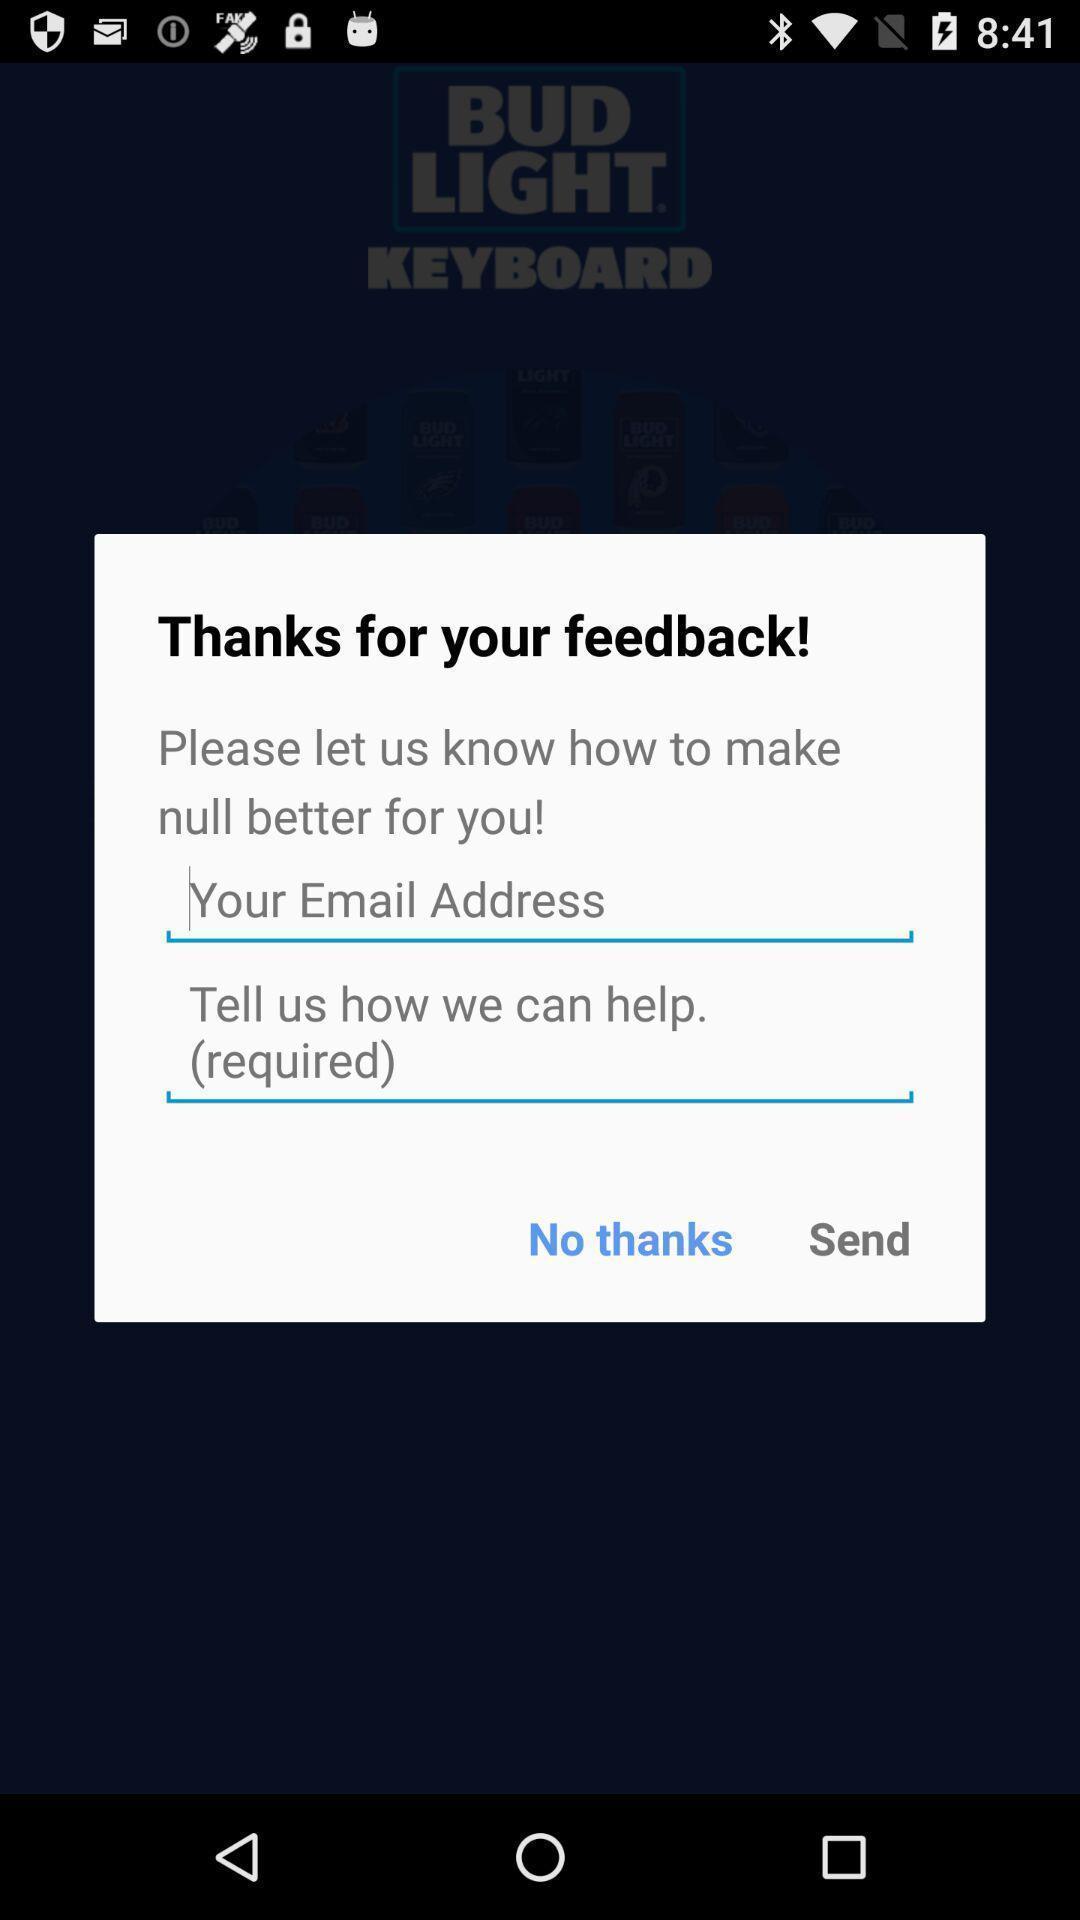Summarize the main components in this picture. Pop up window of feedback. 